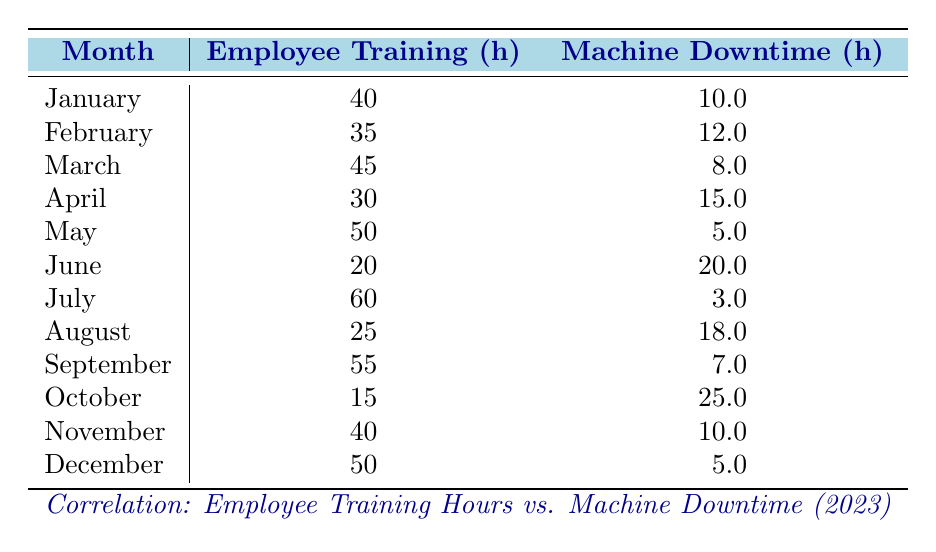What are the Machine Downtime Hours for July? The table lists the Machine Downtime Hours for each month. In the row for July, it shows that the Machine Downtime Hours is 3.0.
Answer: 3.0 What is the total Employee Training Hours for the first quarter (January to March)? The Employee Training Hours for January, February, and March are 40, 35, and 45 respectively. Adding these gives 40 + 35 + 45 = 120.
Answer: 120 Is the Machine Downtime Hours higher in April than in March? According to the table, the Machine Downtime Hours in April is 15.0 while in March it is 8.0. Since 15.0 is greater than 8.0, the statement is true.
Answer: Yes What is the average Employee Training Hours over the entire year? To find the average, add the Employee Training Hours for all months (40+35+45+30+50+20+60+25+55+15+40+50 = 450) and divide by 12 (the number of months): 450/12 = 37.5.
Answer: 37.5 Which month had the least Machine Downtime Hours? In the Machine Downtime Hours column, the smallest value is 3.0, which occurs in July.
Answer: July Does an increase in Employee Training Hours correlate with a decrease in Machine Downtime Hours in the data? By examining the table, when Employee Training Hours increase (such as from May to June with a drop in Downtime from 5 to 20), it shows an inverse relationship, suggesting a negative correlation.
Answer: Yes What is the difference in Machine Downtime Hours between the months with the highest and lowest Employee Training Hours? The month with the highest Employee Training Hours is July (60) and has 3.0 Downtime Hours. The month with the lowest Training Hours is June (20), which has 20.0 Downtime Hours. The difference is 20.0 - 3.0 = 17.0.
Answer: 17.0 Which month had equal Employee Training and Machine Downtime Hours? By looking at the table, no month has both equal Employee Training Hours and Machine Downtime Hours; this can be concluded by checking each month.
Answer: None What is the trend in Employee Training Hours from June to December? From June to December, the Employee Training Hours are 20, 60, 25, 55, 15, and 50 respectively. As we see, the numbers fluctuate, with no consistent increase or decrease overall.
Answer: Fluctuating trend 